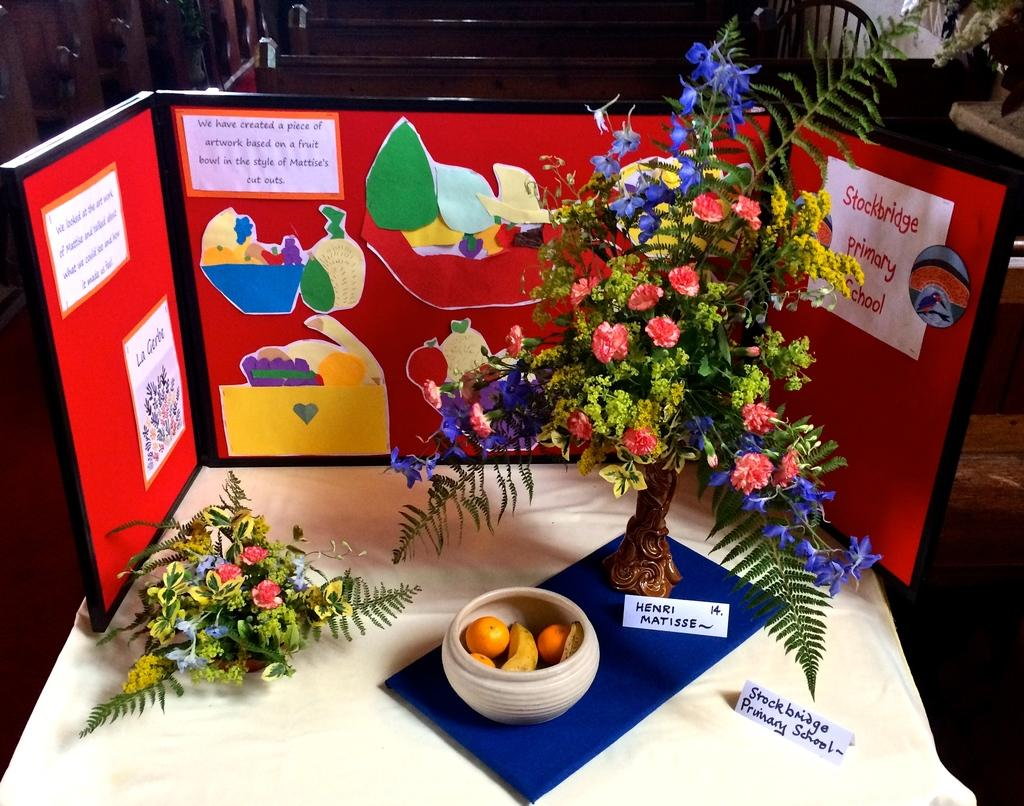What is the main object in the center of the image? There is a table in the center of the image. What can be found on the table? There are many objects on the table. Can you see the mom pushing a carriage in the image? There is no mom or carriage present in the image. Is it possible to touch the objects on the table in the image? The image is a static representation, so it is not possible to touch the objects on the table through the image. 